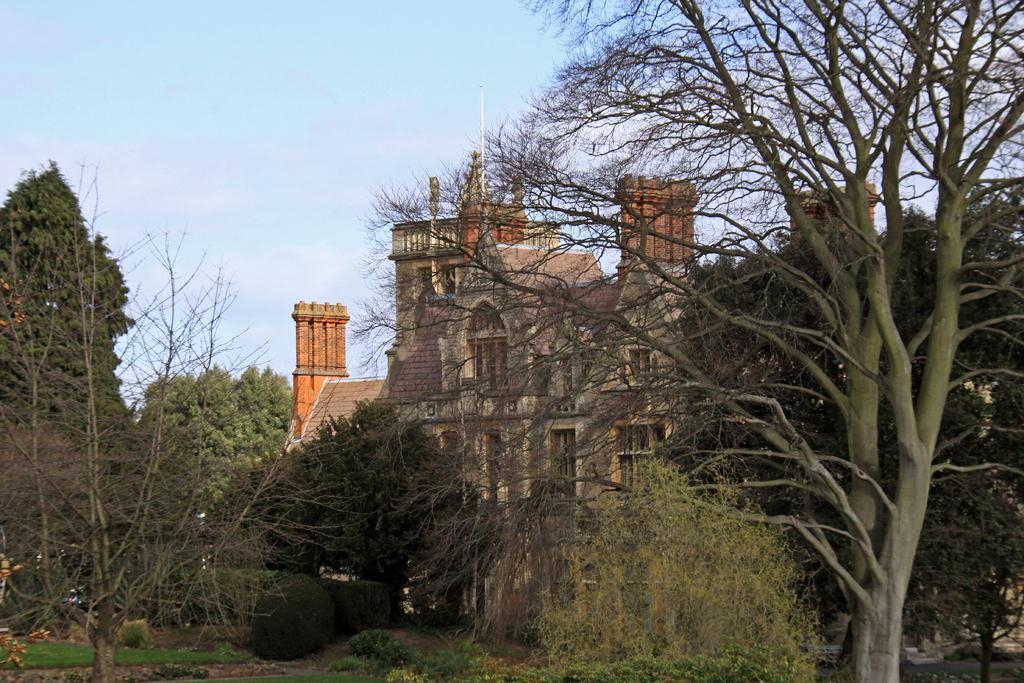Please provide a concise description of this image. In this picture we can see plants, trees, buildings with windows and in the background we can see the sky. 